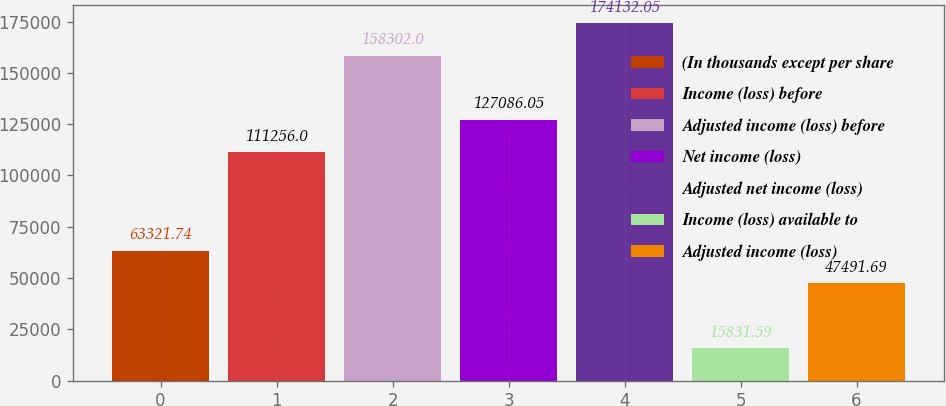Convert chart. <chart><loc_0><loc_0><loc_500><loc_500><bar_chart><fcel>(In thousands except per share<fcel>Income (loss) before<fcel>Adjusted income (loss) before<fcel>Net income (loss)<fcel>Adjusted net income (loss)<fcel>Income (loss) available to<fcel>Adjusted income (loss)<nl><fcel>63321.7<fcel>111256<fcel>158302<fcel>127086<fcel>174132<fcel>15831.6<fcel>47491.7<nl></chart> 